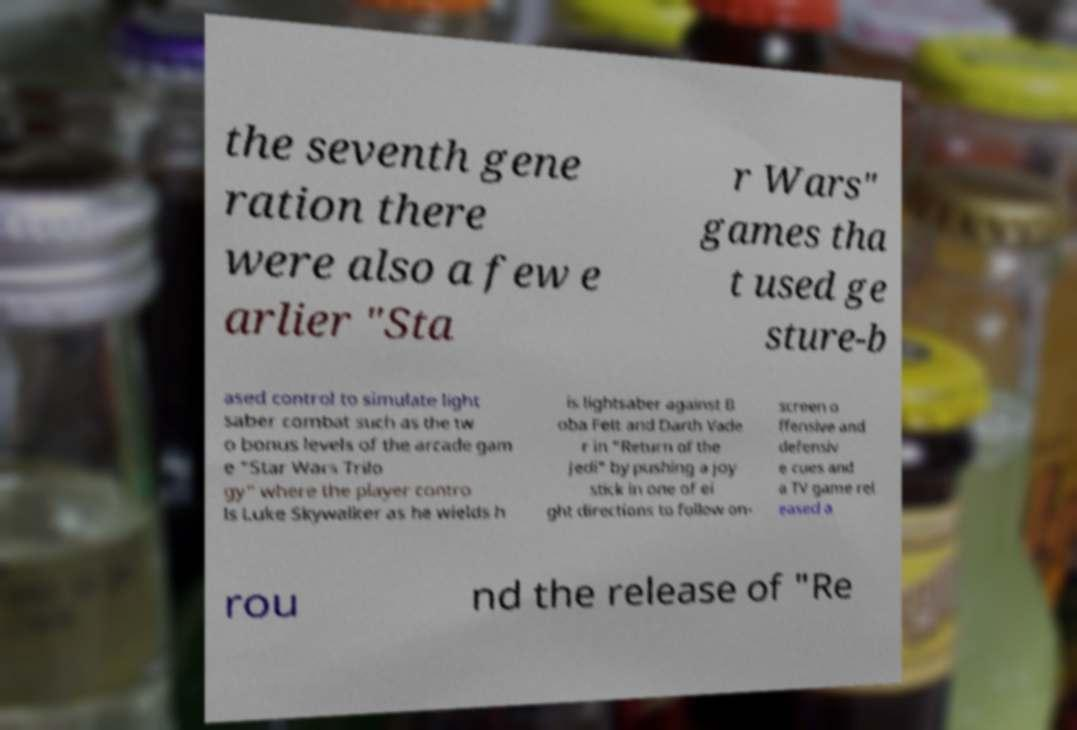Can you accurately transcribe the text from the provided image for me? the seventh gene ration there were also a few e arlier "Sta r Wars" games tha t used ge sture-b ased control to simulate light saber combat such as the tw o bonus levels of the arcade gam e "Star Wars Trilo gy" where the player contro ls Luke Skywalker as he wields h is lightsaber against B oba Fett and Darth Vade r in "Return of the Jedi" by pushing a joy stick in one of ei ght directions to follow on- screen o ffensive and defensiv e cues and a TV game rel eased a rou nd the release of "Re 